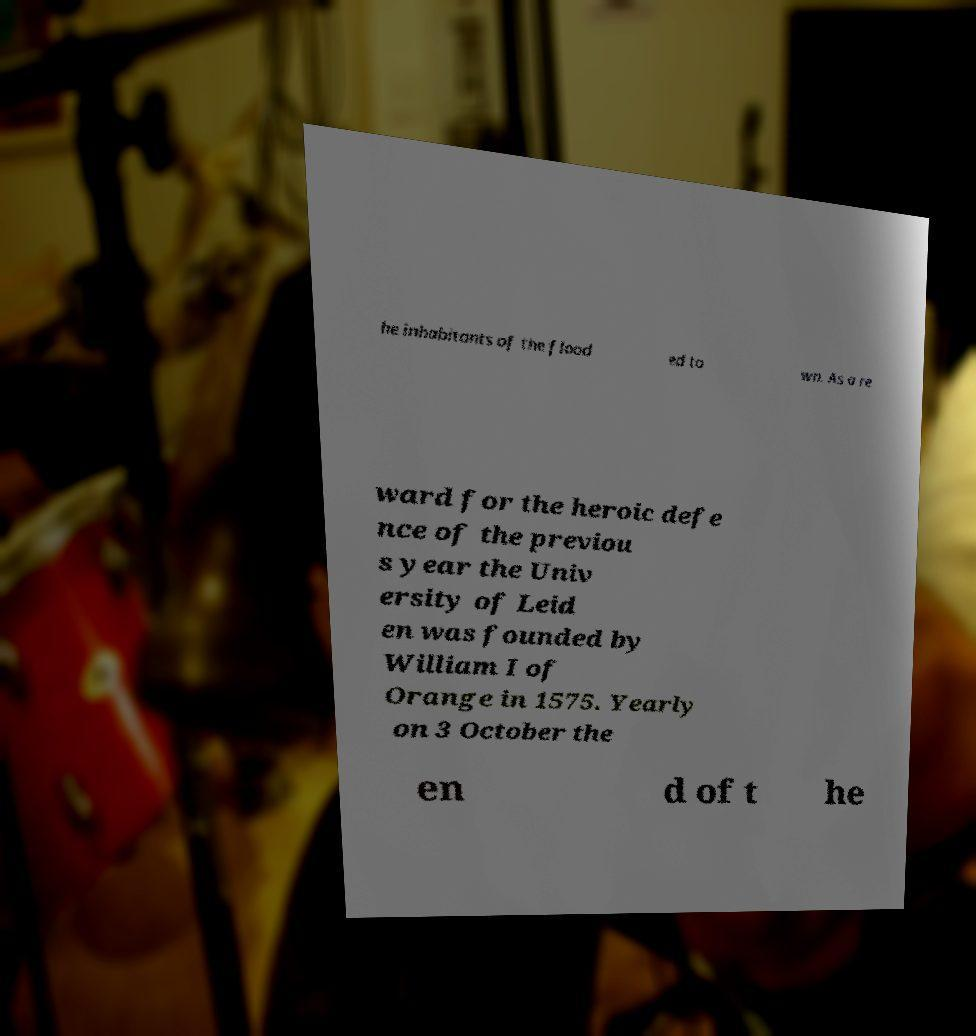There's text embedded in this image that I need extracted. Can you transcribe it verbatim? he inhabitants of the flood ed to wn. As a re ward for the heroic defe nce of the previou s year the Univ ersity of Leid en was founded by William I of Orange in 1575. Yearly on 3 October the en d of t he 